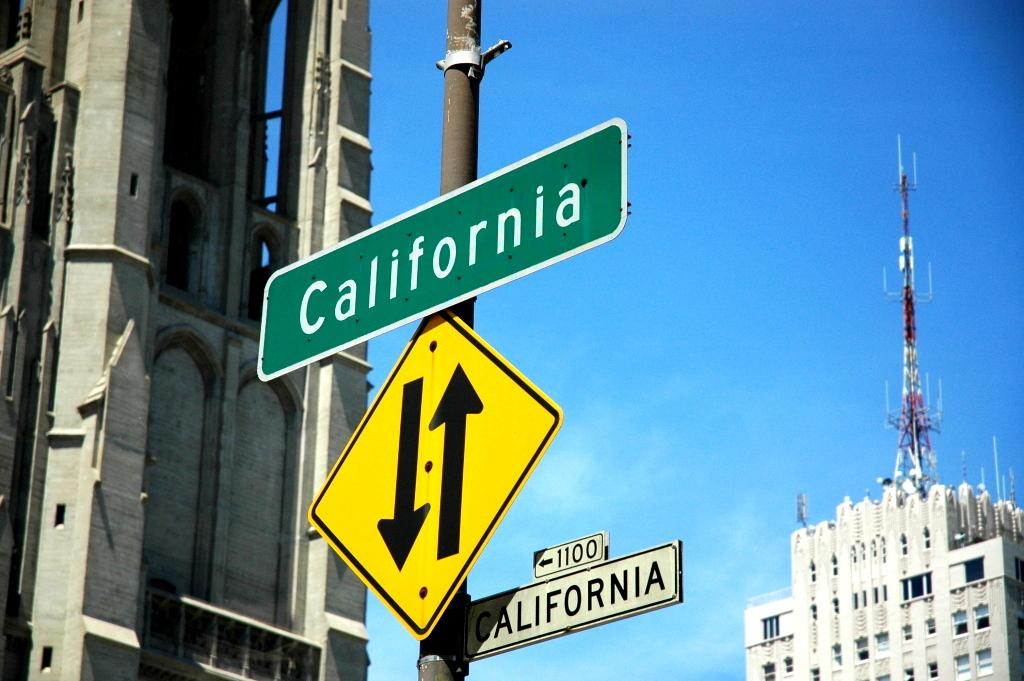<image>
Provide a brief description of the given image. Green street sign that says California on it above another sign. 